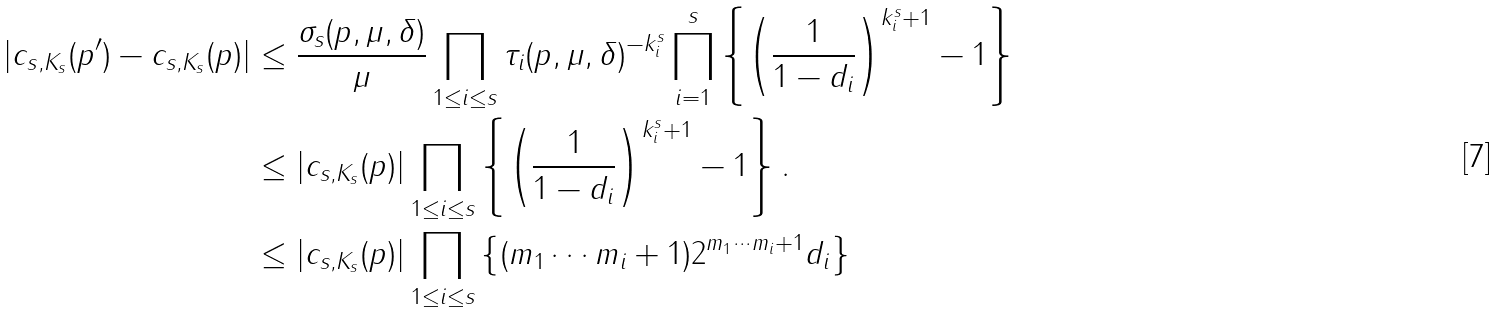<formula> <loc_0><loc_0><loc_500><loc_500>| c _ { s , K _ { s } } ( p ^ { \prime } ) - c _ { s , K _ { s } } ( p ) | & \leq \frac { \sigma _ { s } ( p , \mu , \delta ) } { \mu } \prod _ { 1 \leq i \leq s } \tau _ { i } ( p , \mu , \delta ) ^ { - k _ { i } ^ { s } } \prod _ { i = 1 } ^ { s } \left \{ \left ( \frac { 1 } { 1 - d _ { i } } \right ) ^ { k _ { i } ^ { s } + 1 } - 1 \right \} \\ & \leq | c _ { s , K _ { s } } ( p ) | \prod _ { 1 \leq i \leq s } \left \{ \left ( \frac { 1 } { 1 - d _ { i } } \right ) ^ { k _ { i } ^ { s } + 1 } - 1 \right \} . \\ & \leq | c _ { s , K _ { s } } ( p ) | \prod _ { 1 \leq i \leq s } \left \{ ( m _ { 1 } \cdots m _ { i } + 1 ) 2 ^ { m _ { 1 } \cdots m _ { i } + 1 } d _ { i } \right \}</formula> 